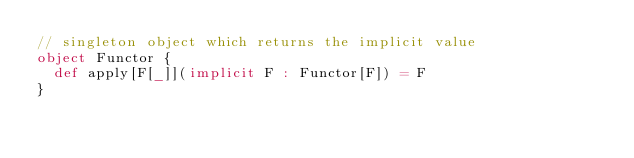Convert code to text. <code><loc_0><loc_0><loc_500><loc_500><_Scala_>// singleton object which returns the implicit value
object Functor {
  def apply[F[_]](implicit F : Functor[F]) = F
}

</code> 